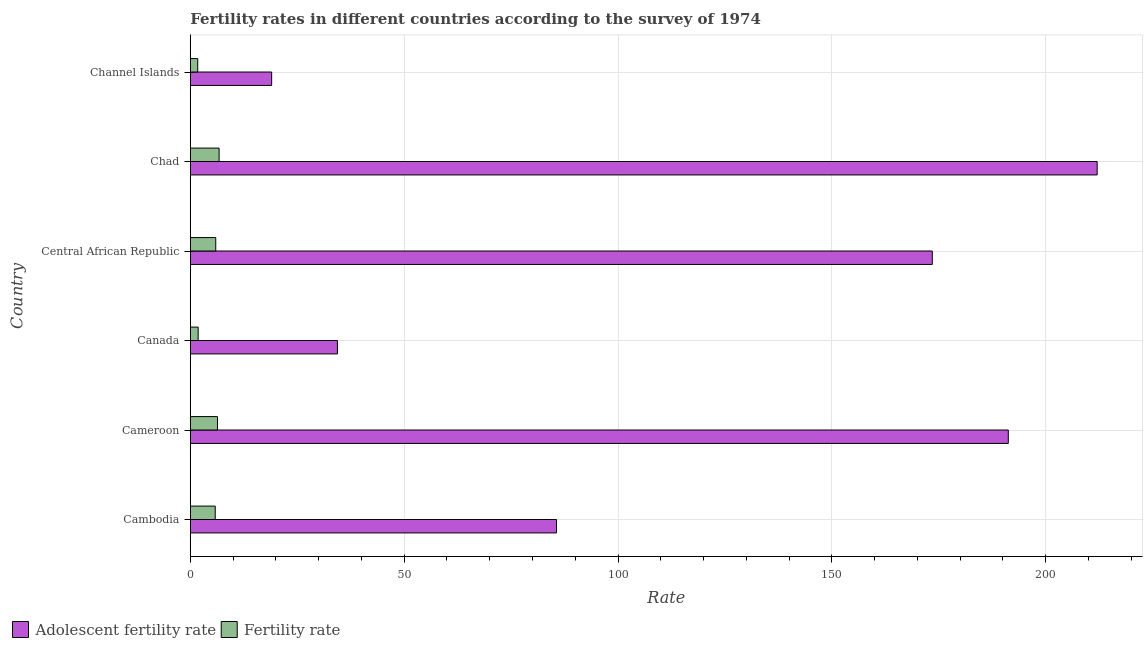How many groups of bars are there?
Give a very brief answer. 6. Are the number of bars per tick equal to the number of legend labels?
Offer a very short reply. Yes. How many bars are there on the 2nd tick from the bottom?
Provide a succinct answer. 2. What is the label of the 6th group of bars from the top?
Keep it short and to the point. Cambodia. In how many cases, is the number of bars for a given country not equal to the number of legend labels?
Provide a short and direct response. 0. What is the adolescent fertility rate in Channel Islands?
Provide a short and direct response. 19.02. Across all countries, what is the maximum fertility rate?
Ensure brevity in your answer.  6.74. Across all countries, what is the minimum adolescent fertility rate?
Your answer should be compact. 19.02. In which country was the adolescent fertility rate maximum?
Provide a succinct answer. Chad. In which country was the fertility rate minimum?
Your response must be concise. Channel Islands. What is the total fertility rate in the graph?
Offer a very short reply. 28.45. What is the difference between the adolescent fertility rate in Chad and that in Channel Islands?
Provide a succinct answer. 193. What is the difference between the adolescent fertility rate in Chad and the fertility rate in Channel Islands?
Ensure brevity in your answer.  210.28. What is the average adolescent fertility rate per country?
Provide a short and direct response. 119.3. What is the difference between the adolescent fertility rate and fertility rate in Canada?
Make the answer very short. 32.56. What is the ratio of the adolescent fertility rate in Cameroon to that in Central African Republic?
Your response must be concise. 1.1. What is the difference between the highest and the second highest adolescent fertility rate?
Ensure brevity in your answer.  20.77. What is the difference between the highest and the lowest adolescent fertility rate?
Offer a terse response. 193. In how many countries, is the fertility rate greater than the average fertility rate taken over all countries?
Make the answer very short. 4. What does the 1st bar from the top in Central African Republic represents?
Your response must be concise. Fertility rate. What does the 2nd bar from the bottom in Cameroon represents?
Offer a very short reply. Fertility rate. How many bars are there?
Your answer should be very brief. 12. How many countries are there in the graph?
Ensure brevity in your answer.  6. How many legend labels are there?
Your answer should be very brief. 2. How are the legend labels stacked?
Your response must be concise. Horizontal. What is the title of the graph?
Keep it short and to the point. Fertility rates in different countries according to the survey of 1974. What is the label or title of the X-axis?
Offer a very short reply. Rate. What is the label or title of the Y-axis?
Your answer should be very brief. Country. What is the Rate in Adolescent fertility rate in Cambodia?
Offer a very short reply. 85.62. What is the Rate in Fertility rate in Cambodia?
Give a very brief answer. 5.83. What is the Rate of Adolescent fertility rate in Cameroon?
Keep it short and to the point. 191.25. What is the Rate in Fertility rate in Cameroon?
Your response must be concise. 6.36. What is the Rate in Adolescent fertility rate in Canada?
Your answer should be very brief. 34.4. What is the Rate of Fertility rate in Canada?
Ensure brevity in your answer.  1.84. What is the Rate in Adolescent fertility rate in Central African Republic?
Give a very brief answer. 173.48. What is the Rate in Fertility rate in Central African Republic?
Your answer should be very brief. 5.95. What is the Rate of Adolescent fertility rate in Chad?
Keep it short and to the point. 212.02. What is the Rate of Fertility rate in Chad?
Offer a terse response. 6.74. What is the Rate in Adolescent fertility rate in Channel Islands?
Make the answer very short. 19.02. What is the Rate of Fertility rate in Channel Islands?
Give a very brief answer. 1.74. Across all countries, what is the maximum Rate in Adolescent fertility rate?
Ensure brevity in your answer.  212.02. Across all countries, what is the maximum Rate in Fertility rate?
Keep it short and to the point. 6.74. Across all countries, what is the minimum Rate of Adolescent fertility rate?
Your answer should be very brief. 19.02. Across all countries, what is the minimum Rate of Fertility rate?
Provide a succinct answer. 1.74. What is the total Rate in Adolescent fertility rate in the graph?
Offer a very short reply. 715.79. What is the total Rate in Fertility rate in the graph?
Offer a very short reply. 28.45. What is the difference between the Rate in Adolescent fertility rate in Cambodia and that in Cameroon?
Your answer should be very brief. -105.63. What is the difference between the Rate of Fertility rate in Cambodia and that in Cameroon?
Give a very brief answer. -0.53. What is the difference between the Rate of Adolescent fertility rate in Cambodia and that in Canada?
Provide a short and direct response. 51.22. What is the difference between the Rate of Fertility rate in Cambodia and that in Canada?
Keep it short and to the point. 3.99. What is the difference between the Rate of Adolescent fertility rate in Cambodia and that in Central African Republic?
Provide a short and direct response. -87.86. What is the difference between the Rate of Fertility rate in Cambodia and that in Central African Republic?
Offer a terse response. -0.12. What is the difference between the Rate in Adolescent fertility rate in Cambodia and that in Chad?
Make the answer very short. -126.4. What is the difference between the Rate in Fertility rate in Cambodia and that in Chad?
Your response must be concise. -0.91. What is the difference between the Rate in Adolescent fertility rate in Cambodia and that in Channel Islands?
Keep it short and to the point. 66.6. What is the difference between the Rate in Fertility rate in Cambodia and that in Channel Islands?
Your answer should be very brief. 4.1. What is the difference between the Rate of Adolescent fertility rate in Cameroon and that in Canada?
Offer a terse response. 156.85. What is the difference between the Rate of Fertility rate in Cameroon and that in Canada?
Make the answer very short. 4.52. What is the difference between the Rate in Adolescent fertility rate in Cameroon and that in Central African Republic?
Provide a short and direct response. 17.77. What is the difference between the Rate in Fertility rate in Cameroon and that in Central African Republic?
Ensure brevity in your answer.  0.41. What is the difference between the Rate of Adolescent fertility rate in Cameroon and that in Chad?
Keep it short and to the point. -20.77. What is the difference between the Rate in Fertility rate in Cameroon and that in Chad?
Make the answer very short. -0.38. What is the difference between the Rate in Adolescent fertility rate in Cameroon and that in Channel Islands?
Make the answer very short. 172.22. What is the difference between the Rate of Fertility rate in Cameroon and that in Channel Islands?
Make the answer very short. 4.62. What is the difference between the Rate of Adolescent fertility rate in Canada and that in Central African Republic?
Your response must be concise. -139.08. What is the difference between the Rate in Fertility rate in Canada and that in Central African Republic?
Your response must be concise. -4.11. What is the difference between the Rate in Adolescent fertility rate in Canada and that in Chad?
Give a very brief answer. -177.62. What is the difference between the Rate of Fertility rate in Canada and that in Chad?
Offer a terse response. -4.9. What is the difference between the Rate in Adolescent fertility rate in Canada and that in Channel Islands?
Provide a succinct answer. 15.38. What is the difference between the Rate of Fertility rate in Canada and that in Channel Islands?
Give a very brief answer. 0.1. What is the difference between the Rate of Adolescent fertility rate in Central African Republic and that in Chad?
Your answer should be very brief. -38.54. What is the difference between the Rate in Fertility rate in Central African Republic and that in Chad?
Keep it short and to the point. -0.79. What is the difference between the Rate of Adolescent fertility rate in Central African Republic and that in Channel Islands?
Your answer should be compact. 154.46. What is the difference between the Rate of Fertility rate in Central African Republic and that in Channel Islands?
Provide a succinct answer. 4.22. What is the difference between the Rate in Adolescent fertility rate in Chad and that in Channel Islands?
Give a very brief answer. 193. What is the difference between the Rate of Fertility rate in Chad and that in Channel Islands?
Provide a succinct answer. 5. What is the difference between the Rate of Adolescent fertility rate in Cambodia and the Rate of Fertility rate in Cameroon?
Ensure brevity in your answer.  79.26. What is the difference between the Rate of Adolescent fertility rate in Cambodia and the Rate of Fertility rate in Canada?
Make the answer very short. 83.78. What is the difference between the Rate in Adolescent fertility rate in Cambodia and the Rate in Fertility rate in Central African Republic?
Offer a terse response. 79.67. What is the difference between the Rate of Adolescent fertility rate in Cambodia and the Rate of Fertility rate in Chad?
Keep it short and to the point. 78.88. What is the difference between the Rate in Adolescent fertility rate in Cambodia and the Rate in Fertility rate in Channel Islands?
Ensure brevity in your answer.  83.88. What is the difference between the Rate in Adolescent fertility rate in Cameroon and the Rate in Fertility rate in Canada?
Give a very brief answer. 189.41. What is the difference between the Rate of Adolescent fertility rate in Cameroon and the Rate of Fertility rate in Central African Republic?
Offer a very short reply. 185.3. What is the difference between the Rate of Adolescent fertility rate in Cameroon and the Rate of Fertility rate in Chad?
Ensure brevity in your answer.  184.51. What is the difference between the Rate in Adolescent fertility rate in Cameroon and the Rate in Fertility rate in Channel Islands?
Give a very brief answer. 189.51. What is the difference between the Rate in Adolescent fertility rate in Canada and the Rate in Fertility rate in Central African Republic?
Give a very brief answer. 28.45. What is the difference between the Rate in Adolescent fertility rate in Canada and the Rate in Fertility rate in Chad?
Your response must be concise. 27.66. What is the difference between the Rate of Adolescent fertility rate in Canada and the Rate of Fertility rate in Channel Islands?
Your answer should be compact. 32.67. What is the difference between the Rate of Adolescent fertility rate in Central African Republic and the Rate of Fertility rate in Chad?
Ensure brevity in your answer.  166.74. What is the difference between the Rate of Adolescent fertility rate in Central African Republic and the Rate of Fertility rate in Channel Islands?
Your answer should be compact. 171.74. What is the difference between the Rate of Adolescent fertility rate in Chad and the Rate of Fertility rate in Channel Islands?
Your answer should be compact. 210.28. What is the average Rate in Adolescent fertility rate per country?
Keep it short and to the point. 119.3. What is the average Rate of Fertility rate per country?
Your answer should be very brief. 4.74. What is the difference between the Rate of Adolescent fertility rate and Rate of Fertility rate in Cambodia?
Your answer should be very brief. 79.79. What is the difference between the Rate in Adolescent fertility rate and Rate in Fertility rate in Cameroon?
Offer a terse response. 184.89. What is the difference between the Rate in Adolescent fertility rate and Rate in Fertility rate in Canada?
Your answer should be compact. 32.56. What is the difference between the Rate in Adolescent fertility rate and Rate in Fertility rate in Central African Republic?
Offer a terse response. 167.53. What is the difference between the Rate of Adolescent fertility rate and Rate of Fertility rate in Chad?
Keep it short and to the point. 205.28. What is the difference between the Rate in Adolescent fertility rate and Rate in Fertility rate in Channel Islands?
Your answer should be compact. 17.29. What is the ratio of the Rate in Adolescent fertility rate in Cambodia to that in Cameroon?
Your response must be concise. 0.45. What is the ratio of the Rate of Fertility rate in Cambodia to that in Cameroon?
Provide a short and direct response. 0.92. What is the ratio of the Rate in Adolescent fertility rate in Cambodia to that in Canada?
Provide a short and direct response. 2.49. What is the ratio of the Rate in Fertility rate in Cambodia to that in Canada?
Your response must be concise. 3.17. What is the ratio of the Rate in Adolescent fertility rate in Cambodia to that in Central African Republic?
Provide a succinct answer. 0.49. What is the ratio of the Rate of Fertility rate in Cambodia to that in Central African Republic?
Give a very brief answer. 0.98. What is the ratio of the Rate in Adolescent fertility rate in Cambodia to that in Chad?
Provide a succinct answer. 0.4. What is the ratio of the Rate of Fertility rate in Cambodia to that in Chad?
Make the answer very short. 0.87. What is the ratio of the Rate in Adolescent fertility rate in Cambodia to that in Channel Islands?
Offer a very short reply. 4.5. What is the ratio of the Rate of Fertility rate in Cambodia to that in Channel Islands?
Ensure brevity in your answer.  3.36. What is the ratio of the Rate in Adolescent fertility rate in Cameroon to that in Canada?
Make the answer very short. 5.56. What is the ratio of the Rate of Fertility rate in Cameroon to that in Canada?
Your answer should be very brief. 3.46. What is the ratio of the Rate in Adolescent fertility rate in Cameroon to that in Central African Republic?
Keep it short and to the point. 1.1. What is the ratio of the Rate of Fertility rate in Cameroon to that in Central African Republic?
Offer a very short reply. 1.07. What is the ratio of the Rate of Adolescent fertility rate in Cameroon to that in Chad?
Make the answer very short. 0.9. What is the ratio of the Rate in Fertility rate in Cameroon to that in Chad?
Provide a succinct answer. 0.94. What is the ratio of the Rate in Adolescent fertility rate in Cameroon to that in Channel Islands?
Ensure brevity in your answer.  10.05. What is the ratio of the Rate of Fertility rate in Cameroon to that in Channel Islands?
Your response must be concise. 3.66. What is the ratio of the Rate of Adolescent fertility rate in Canada to that in Central African Republic?
Offer a terse response. 0.2. What is the ratio of the Rate of Fertility rate in Canada to that in Central African Republic?
Provide a short and direct response. 0.31. What is the ratio of the Rate in Adolescent fertility rate in Canada to that in Chad?
Your response must be concise. 0.16. What is the ratio of the Rate in Fertility rate in Canada to that in Chad?
Your response must be concise. 0.27. What is the ratio of the Rate in Adolescent fertility rate in Canada to that in Channel Islands?
Keep it short and to the point. 1.81. What is the ratio of the Rate of Fertility rate in Canada to that in Channel Islands?
Ensure brevity in your answer.  1.06. What is the ratio of the Rate of Adolescent fertility rate in Central African Republic to that in Chad?
Provide a succinct answer. 0.82. What is the ratio of the Rate in Fertility rate in Central African Republic to that in Chad?
Offer a terse response. 0.88. What is the ratio of the Rate of Adolescent fertility rate in Central African Republic to that in Channel Islands?
Your response must be concise. 9.12. What is the ratio of the Rate in Fertility rate in Central African Republic to that in Channel Islands?
Provide a succinct answer. 3.43. What is the ratio of the Rate of Adolescent fertility rate in Chad to that in Channel Islands?
Offer a very short reply. 11.15. What is the ratio of the Rate of Fertility rate in Chad to that in Channel Islands?
Offer a terse response. 3.88. What is the difference between the highest and the second highest Rate of Adolescent fertility rate?
Provide a succinct answer. 20.77. What is the difference between the highest and the second highest Rate of Fertility rate?
Offer a very short reply. 0.38. What is the difference between the highest and the lowest Rate in Adolescent fertility rate?
Provide a succinct answer. 193. What is the difference between the highest and the lowest Rate in Fertility rate?
Keep it short and to the point. 5. 